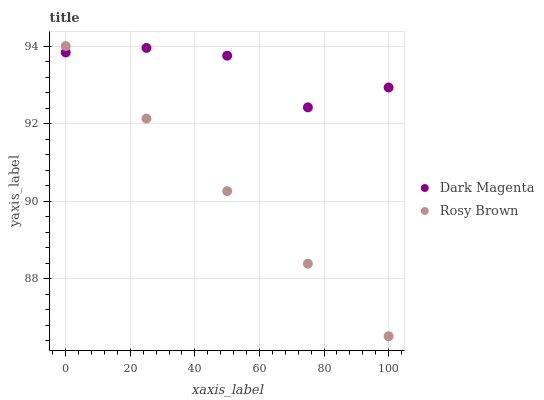Does Rosy Brown have the minimum area under the curve?
Answer yes or no. Yes. Does Dark Magenta have the maximum area under the curve?
Answer yes or no. Yes. Does Dark Magenta have the minimum area under the curve?
Answer yes or no. No. Is Rosy Brown the smoothest?
Answer yes or no. Yes. Is Dark Magenta the roughest?
Answer yes or no. Yes. Is Dark Magenta the smoothest?
Answer yes or no. No. Does Rosy Brown have the lowest value?
Answer yes or no. Yes. Does Dark Magenta have the lowest value?
Answer yes or no. No. Does Rosy Brown have the highest value?
Answer yes or no. Yes. Does Dark Magenta have the highest value?
Answer yes or no. No. Does Rosy Brown intersect Dark Magenta?
Answer yes or no. Yes. Is Rosy Brown less than Dark Magenta?
Answer yes or no. No. Is Rosy Brown greater than Dark Magenta?
Answer yes or no. No. 